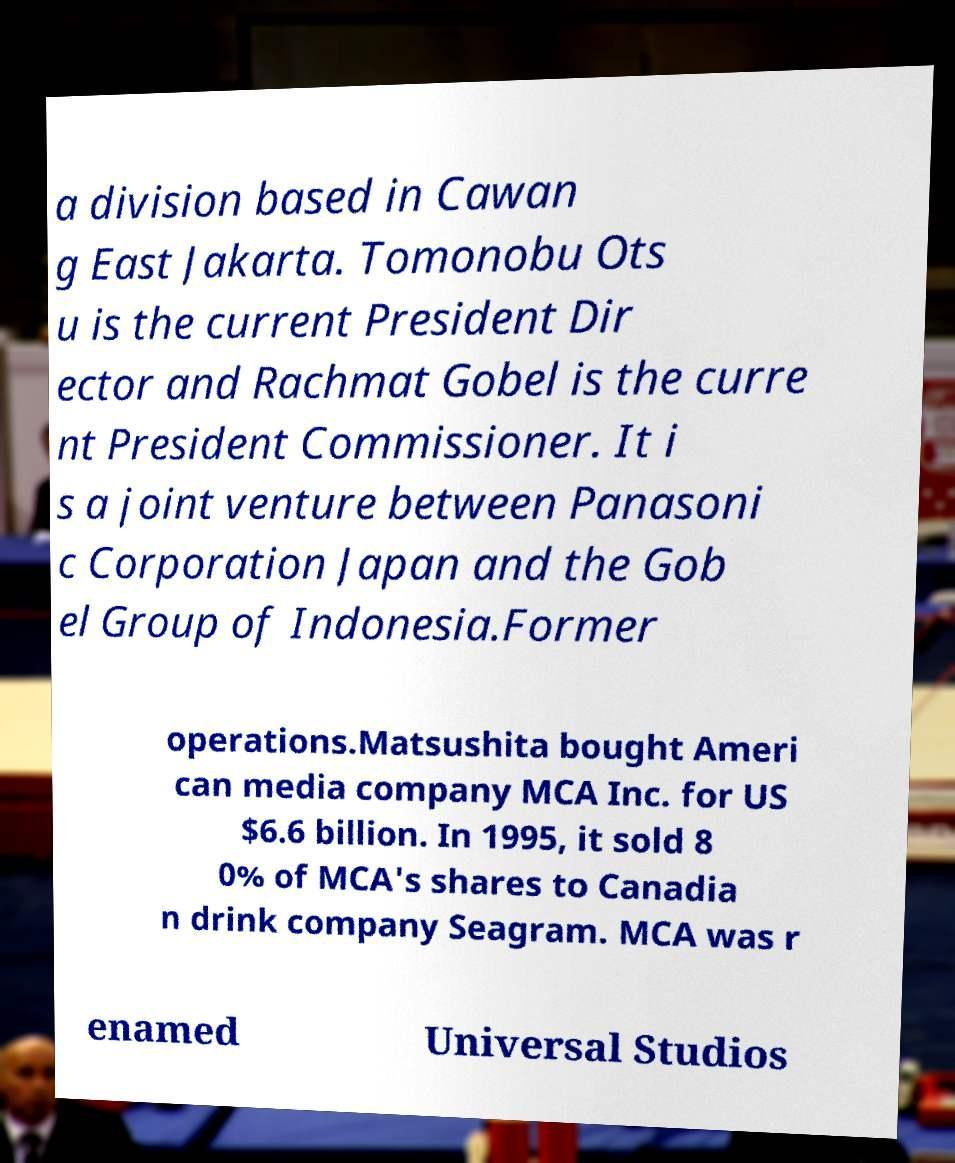Please identify and transcribe the text found in this image. a division based in Cawan g East Jakarta. Tomonobu Ots u is the current President Dir ector and Rachmat Gobel is the curre nt President Commissioner. It i s a joint venture between Panasoni c Corporation Japan and the Gob el Group of Indonesia.Former operations.Matsushita bought Ameri can media company MCA Inc. for US $6.6 billion. In 1995, it sold 8 0% of MCA's shares to Canadia n drink company Seagram. MCA was r enamed Universal Studios 